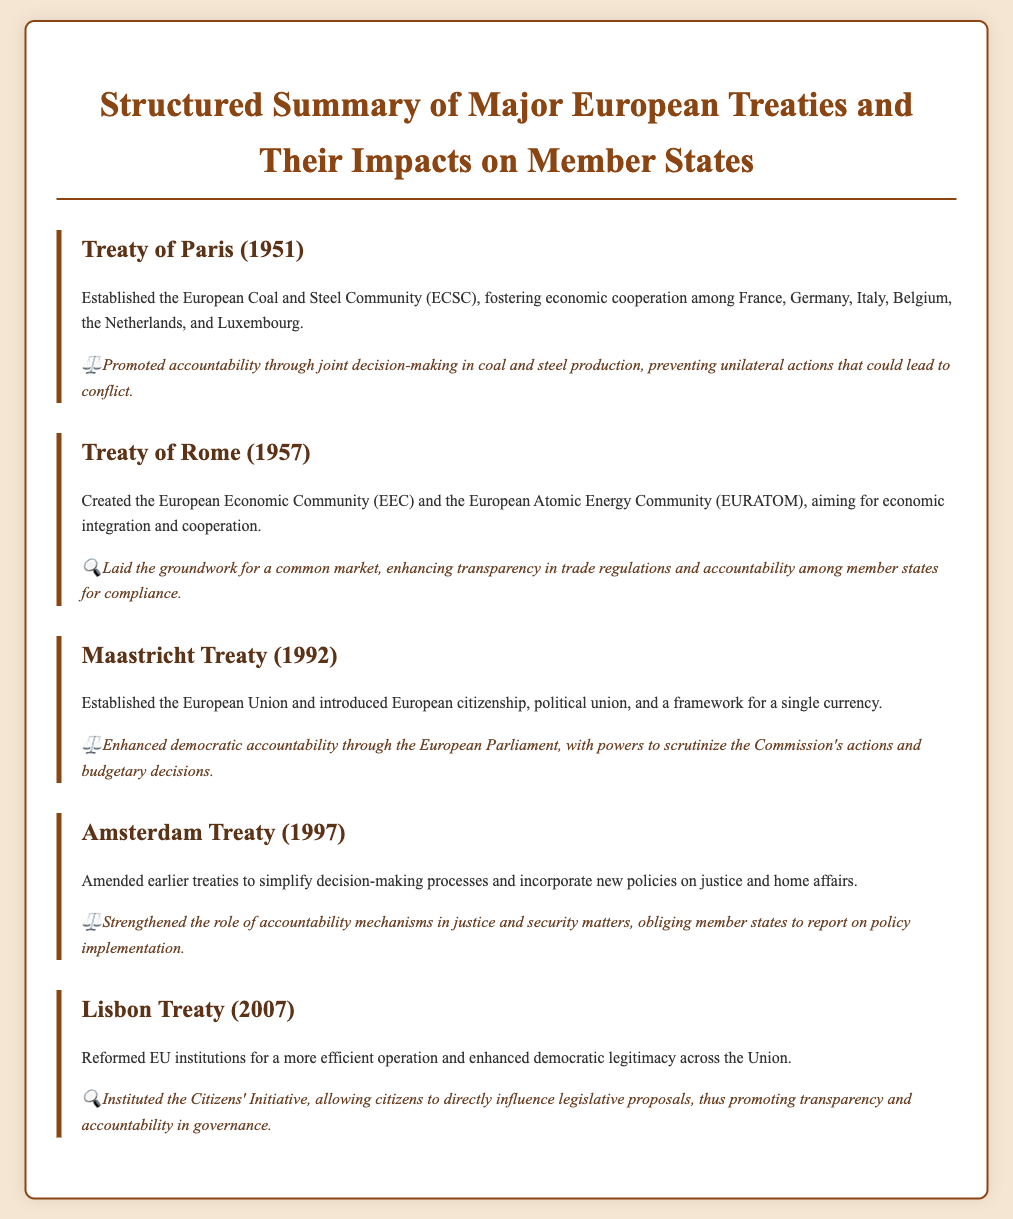What treaty established the ECSC? The document states that the Treaty of Paris (1951) established the European Coal and Steel Community (ECSC).
Answer: Treaty of Paris What year was the Maastricht Treaty signed? The document indicates that the Maastricht Treaty was signed in 1992.
Answer: 1992 What community did the Treaty of Rome create? According to the document, the Treaty of Rome created the European Economic Community (EEC) and the European Atomic Energy Community (EURATOM).
Answer: European Economic Community Which treaty introduced the Citizens' Initiative? The document specifies that the Lisbon Treaty (2007) instituted the Citizens' Initiative.
Answer: Lisbon Treaty How many countries were involved in the ECSC establishment? The text states that six countries were involved in the establishment of the ECSC.
Answer: Six What is one impact of the Amsterdam Treaty? The document mentions that the Amsterdam Treaty strengthened accountability mechanisms in justice and security matters.
Answer: Strengthened accountability mechanisms What does the Maastricht Treaty enhance in terms of governance? It enhances democratic accountability through the European Parliament.
Answer: Democratic accountability Which treaty is associated with the introduction of European citizenship? The document notes that the Maastricht Treaty is associated with the introduction of European citizenship.
Answer: Maastricht Treaty What did the Lisbon Treaty aim to reform? The document indicates that the Lisbon Treaty aimed to reform EU institutions for a more efficient operation.
Answer: EU institutions 